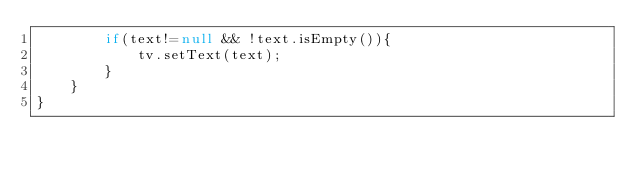<code> <loc_0><loc_0><loc_500><loc_500><_Java_>        if(text!=null && !text.isEmpty()){
            tv.setText(text);
        }
    }
}
</code> 